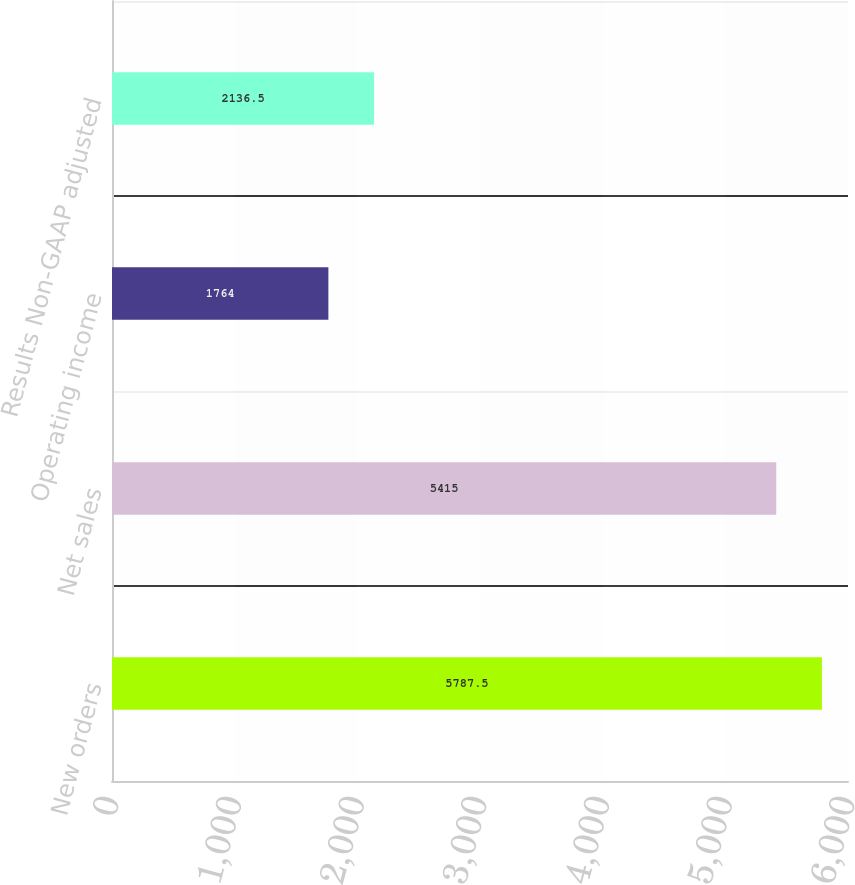<chart> <loc_0><loc_0><loc_500><loc_500><bar_chart><fcel>New orders<fcel>Net sales<fcel>Operating income<fcel>Results Non-GAAP adjusted<nl><fcel>5787.5<fcel>5415<fcel>1764<fcel>2136.5<nl></chart> 